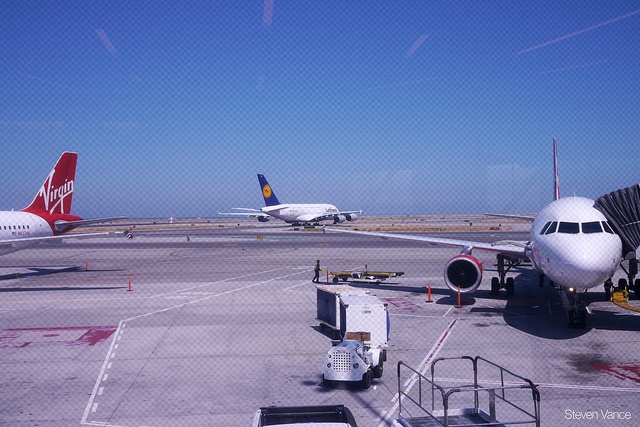Describe the objects in this image and their specific colors. I can see airplane in blue, lavender, gray, black, and purple tones, truck in blue, lavender, navy, black, and darkgray tones, airplane in blue, lavender, navy, gray, and darkgray tones, and people in blue, gray, black, and navy tones in this image. 